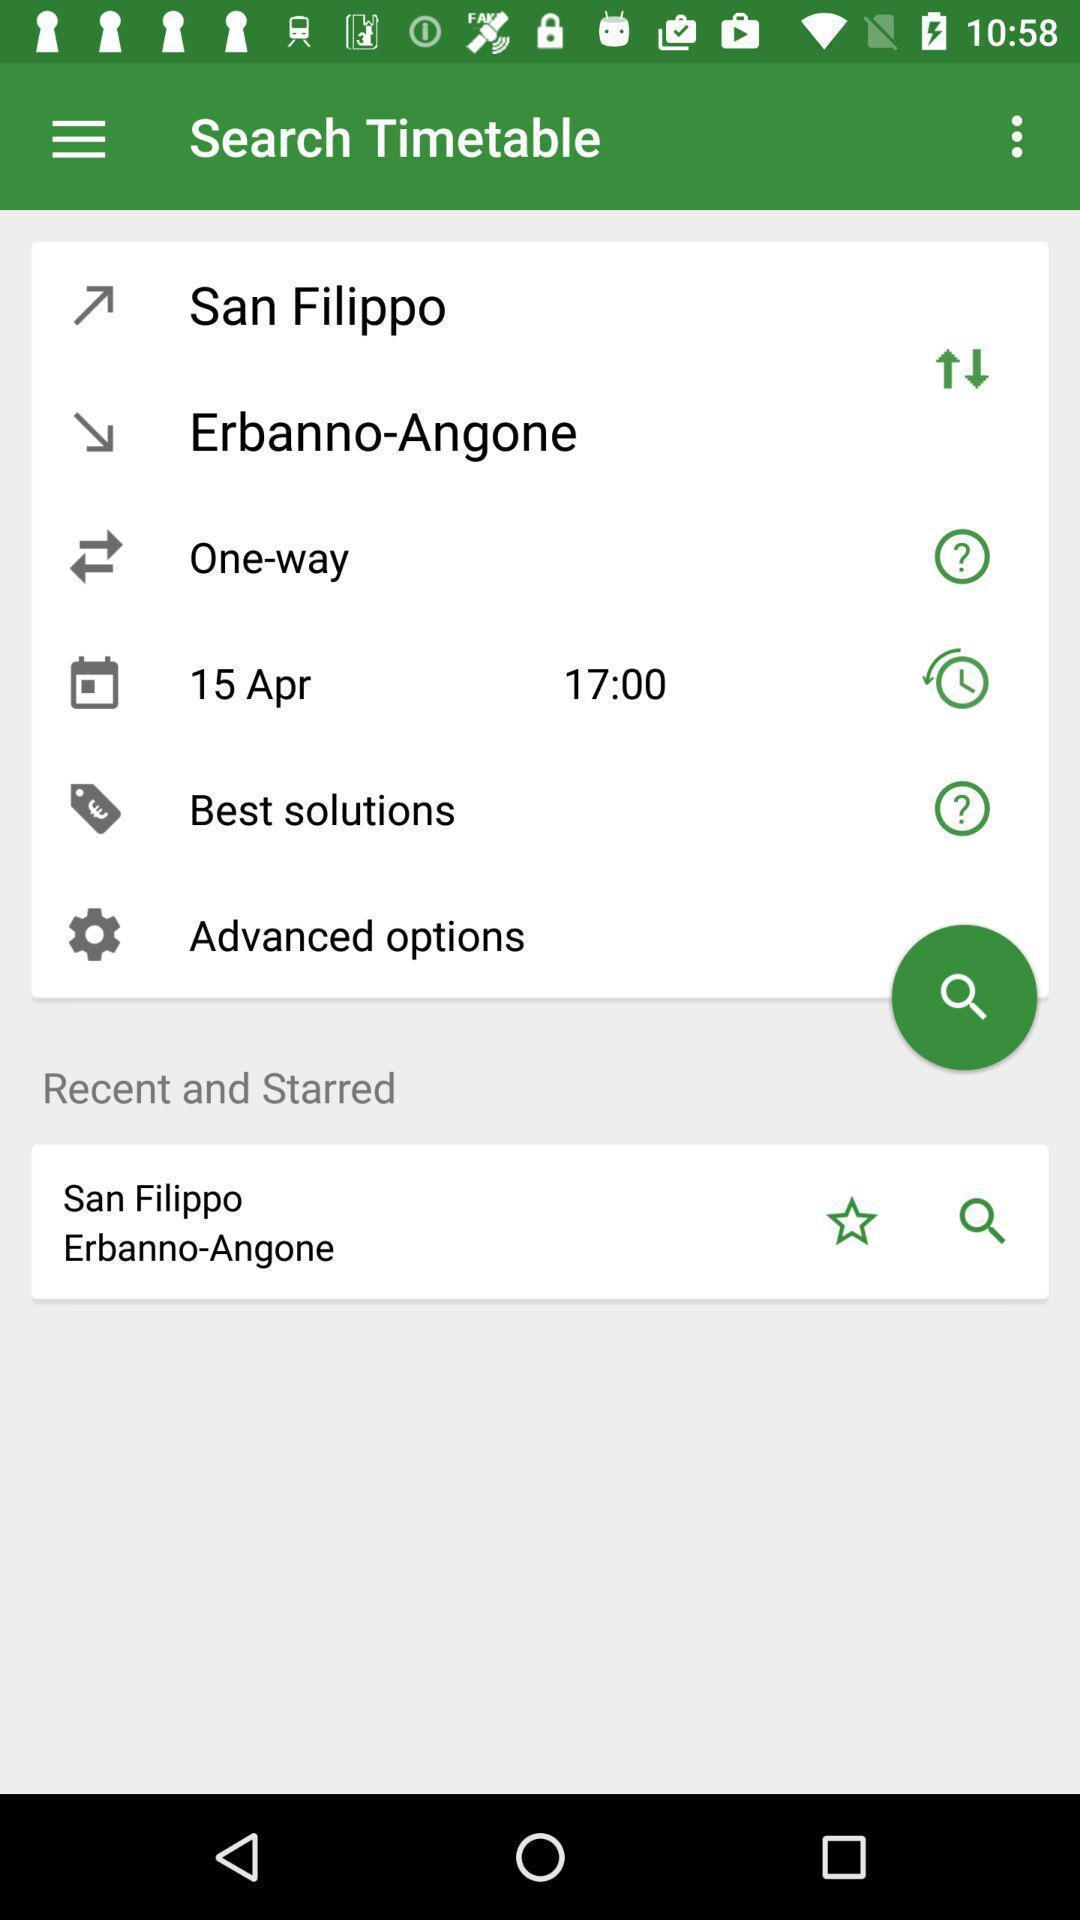Describe the content in this image. Timetable application with scheduled activity. 